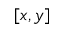<formula> <loc_0><loc_0><loc_500><loc_500>[ x , y ]</formula> 